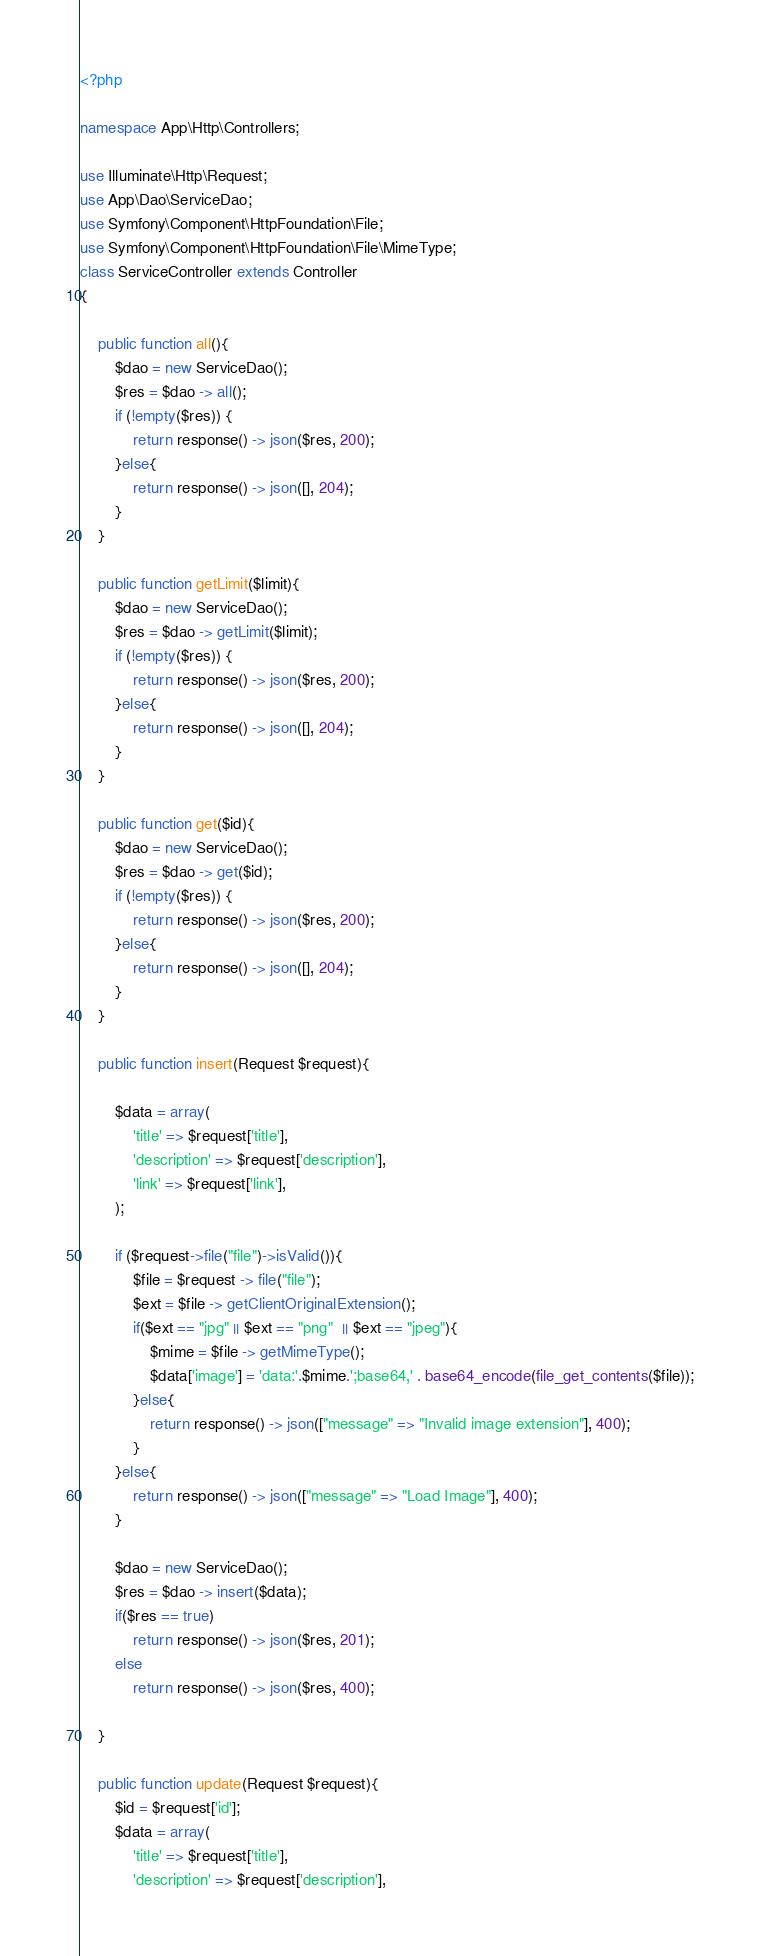Convert code to text. <code><loc_0><loc_0><loc_500><loc_500><_PHP_><?php

namespace App\Http\Controllers;

use Illuminate\Http\Request;
use App\Dao\ServiceDao;
use Symfony\Component\HttpFoundation\File;
use Symfony\Component\HttpFoundation\File\MimeType;
class ServiceController extends Controller
{

    public function all(){
    	$dao = new ServiceDao();
        $res = $dao -> all();
        if (!empty($res)) {
            return response() -> json($res, 200);
        }else{
            return response() -> json([], 204);
        }
    }

    public function getLimit($limit){
    	$dao = new ServiceDao();
        $res = $dao -> getLimit($limit);
        if (!empty($res)) {
            return response() -> json($res, 200);
        }else{
            return response() -> json([], 204);
        }
    }

    public function get($id){
    	$dao = new ServiceDao();
        $res = $dao -> get($id);
        if (!empty($res)) {
            return response() -> json($res, 200);
        }else{
            return response() -> json([], 204);
        }
    }

    public function insert(Request $request){
        
        $data = array(
            'title' => $request['title'],
            'description' => $request['description'],
            'link' => $request['link'],
        );
    
        if ($request->file("file")->isValid()){
            $file = $request -> file("file");
            $ext = $file -> getClientOriginalExtension();
            if($ext == "jpg" || $ext == "png"  || $ext == "jpeg"){
                $mime = $file -> getMimeType();
                $data['image'] = 'data:'.$mime.';base64,' . base64_encode(file_get_contents($file));
            }else{
                return response() -> json(["message" => "Invalid image extension"], 400);
            }
        }else{
            return response() -> json(["message" => "Load Image"], 400);
        }

        $dao = new ServiceDao();
        $res = $dao -> insert($data);
        if($res == true)
            return response() -> json($res, 201);
        else
            return response() -> json($res, 400);

    }

    public function update(Request $request){
        $id = $request['id'];
        $data = array(
            'title' => $request['title'],
            'description' => $request['description'],</code> 